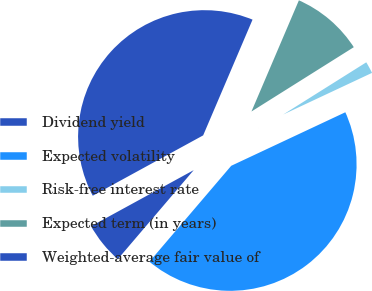<chart> <loc_0><loc_0><loc_500><loc_500><pie_chart><fcel>Dividend yield<fcel>Expected volatility<fcel>Risk-free interest rate<fcel>Expected term (in years)<fcel>Weighted-average fair value of<nl><fcel>5.8%<fcel>43.22%<fcel>1.95%<fcel>9.65%<fcel>39.38%<nl></chart> 